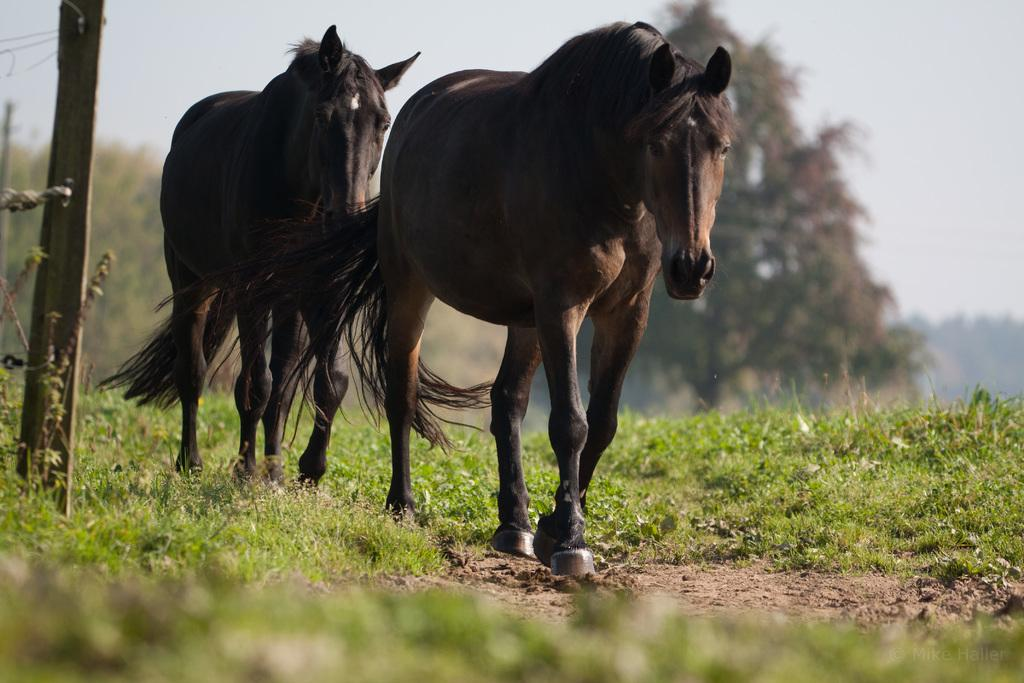How many horses are in the image? There are two horses in the image. What type of surface are the horses standing on? The horses are on a grass surface. What is on the left side of the horses? There is a pole with a barbed wire fence on the left side of the horses. What can be seen behind the horses? There are trees behind the horses. What type of guitar is being played in the image? There is no guitar present in the image; it features two horses on a grass surface with a pole and barbed wire fence on the left side and trees behind them. 